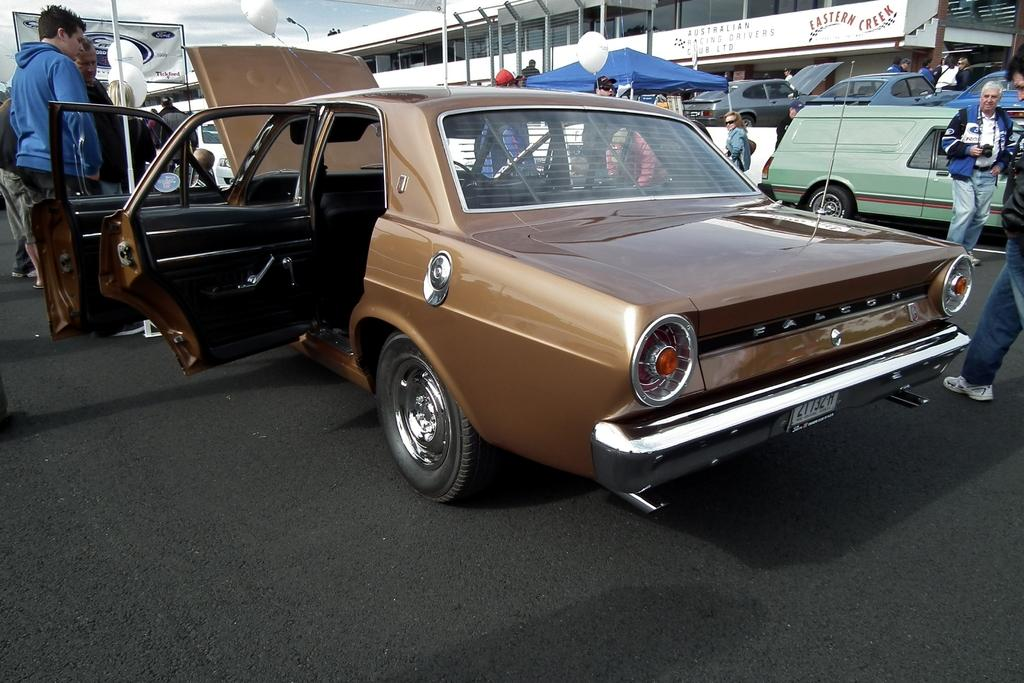Who or what can be seen in the image? There are people in the image. What else is visible on the road in the image? There are vehicles on the road in the image. What can be seen in the distance in the background of the image? There is a building, balloons, a tent, a light, and a banner visible in the background of the image. What part of the natural environment is visible in the image? The sky is visible in the background of the image. What type of rice can be seen cooking in a pot in the image? There is no pot or rice present in the image. Can you tell me how many salt shakers are visible in the image? There is no salt or salt shaker present in the image. 